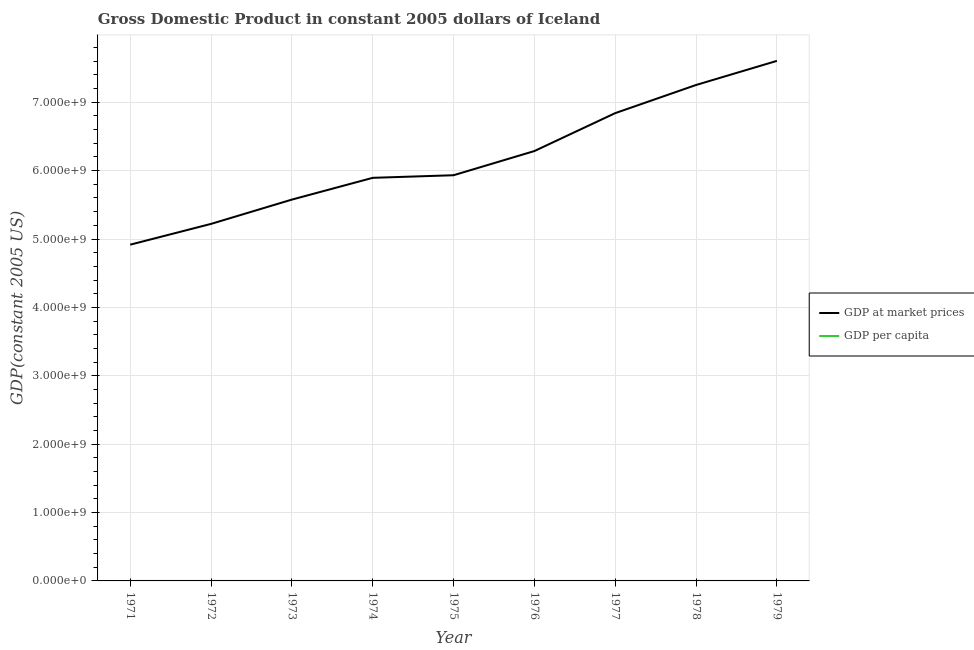How many different coloured lines are there?
Keep it short and to the point. 2. Is the number of lines equal to the number of legend labels?
Provide a succinct answer. Yes. What is the gdp at market prices in 1976?
Offer a very short reply. 6.29e+09. Across all years, what is the maximum gdp at market prices?
Your response must be concise. 7.61e+09. Across all years, what is the minimum gdp per capita?
Keep it short and to the point. 2.39e+04. In which year was the gdp per capita maximum?
Offer a terse response. 1979. In which year was the gdp at market prices minimum?
Make the answer very short. 1971. What is the total gdp at market prices in the graph?
Your answer should be very brief. 5.55e+1. What is the difference between the gdp per capita in 1972 and that in 1979?
Provide a short and direct response. -8725.14. What is the difference between the gdp at market prices in 1974 and the gdp per capita in 1976?
Give a very brief answer. 5.89e+09. What is the average gdp at market prices per year?
Give a very brief answer. 6.17e+09. In the year 1975, what is the difference between the gdp at market prices and gdp per capita?
Provide a short and direct response. 5.93e+09. In how many years, is the gdp per capita greater than 4200000000 US$?
Provide a succinct answer. 0. What is the ratio of the gdp per capita in 1971 to that in 1974?
Your answer should be compact. 0.87. Is the difference between the gdp per capita in 1971 and 1974 greater than the difference between the gdp at market prices in 1971 and 1974?
Keep it short and to the point. Yes. What is the difference between the highest and the second highest gdp at market prices?
Provide a succinct answer. 3.53e+08. What is the difference between the highest and the lowest gdp at market prices?
Your answer should be very brief. 2.69e+09. Is the gdp per capita strictly greater than the gdp at market prices over the years?
Give a very brief answer. No. Is the gdp per capita strictly less than the gdp at market prices over the years?
Provide a succinct answer. Yes. What is the difference between two consecutive major ticks on the Y-axis?
Keep it short and to the point. 1.00e+09. Are the values on the major ticks of Y-axis written in scientific E-notation?
Ensure brevity in your answer.  Yes. Does the graph contain grids?
Keep it short and to the point. Yes. How many legend labels are there?
Your answer should be very brief. 2. What is the title of the graph?
Offer a very short reply. Gross Domestic Product in constant 2005 dollars of Iceland. Does "From human activities" appear as one of the legend labels in the graph?
Your response must be concise. No. What is the label or title of the X-axis?
Keep it short and to the point. Year. What is the label or title of the Y-axis?
Keep it short and to the point. GDP(constant 2005 US). What is the GDP(constant 2005 US) in GDP at market prices in 1971?
Provide a succinct answer. 4.92e+09. What is the GDP(constant 2005 US) in GDP per capita in 1971?
Offer a terse response. 2.39e+04. What is the GDP(constant 2005 US) of GDP at market prices in 1972?
Provide a short and direct response. 5.22e+09. What is the GDP(constant 2005 US) of GDP per capita in 1972?
Ensure brevity in your answer.  2.50e+04. What is the GDP(constant 2005 US) in GDP at market prices in 1973?
Provide a succinct answer. 5.58e+09. What is the GDP(constant 2005 US) of GDP per capita in 1973?
Give a very brief answer. 2.63e+04. What is the GDP(constant 2005 US) in GDP at market prices in 1974?
Your response must be concise. 5.89e+09. What is the GDP(constant 2005 US) of GDP per capita in 1974?
Ensure brevity in your answer.  2.74e+04. What is the GDP(constant 2005 US) of GDP at market prices in 1975?
Keep it short and to the point. 5.93e+09. What is the GDP(constant 2005 US) of GDP per capita in 1975?
Offer a very short reply. 2.72e+04. What is the GDP(constant 2005 US) in GDP at market prices in 1976?
Your response must be concise. 6.29e+09. What is the GDP(constant 2005 US) of GDP per capita in 1976?
Offer a very short reply. 2.86e+04. What is the GDP(constant 2005 US) of GDP at market prices in 1977?
Give a very brief answer. 6.84e+09. What is the GDP(constant 2005 US) of GDP per capita in 1977?
Provide a short and direct response. 3.08e+04. What is the GDP(constant 2005 US) of GDP at market prices in 1978?
Ensure brevity in your answer.  7.25e+09. What is the GDP(constant 2005 US) in GDP per capita in 1978?
Give a very brief answer. 3.24e+04. What is the GDP(constant 2005 US) of GDP at market prices in 1979?
Offer a very short reply. 7.61e+09. What is the GDP(constant 2005 US) of GDP per capita in 1979?
Offer a terse response. 3.37e+04. Across all years, what is the maximum GDP(constant 2005 US) in GDP at market prices?
Provide a succinct answer. 7.61e+09. Across all years, what is the maximum GDP(constant 2005 US) of GDP per capita?
Make the answer very short. 3.37e+04. Across all years, what is the minimum GDP(constant 2005 US) in GDP at market prices?
Ensure brevity in your answer.  4.92e+09. Across all years, what is the minimum GDP(constant 2005 US) in GDP per capita?
Make the answer very short. 2.39e+04. What is the total GDP(constant 2005 US) in GDP at market prices in the graph?
Your response must be concise. 5.55e+1. What is the total GDP(constant 2005 US) of GDP per capita in the graph?
Ensure brevity in your answer.  2.55e+05. What is the difference between the GDP(constant 2005 US) in GDP at market prices in 1971 and that in 1972?
Provide a short and direct response. -3.04e+08. What is the difference between the GDP(constant 2005 US) in GDP per capita in 1971 and that in 1972?
Your answer should be very brief. -1105.76. What is the difference between the GDP(constant 2005 US) in GDP at market prices in 1971 and that in 1973?
Give a very brief answer. -6.59e+08. What is the difference between the GDP(constant 2005 US) of GDP per capita in 1971 and that in 1973?
Ensure brevity in your answer.  -2405.54. What is the difference between the GDP(constant 2005 US) in GDP at market prices in 1971 and that in 1974?
Offer a terse response. -9.77e+08. What is the difference between the GDP(constant 2005 US) of GDP per capita in 1971 and that in 1974?
Ensure brevity in your answer.  -3531.21. What is the difference between the GDP(constant 2005 US) in GDP at market prices in 1971 and that in 1975?
Keep it short and to the point. -1.02e+09. What is the difference between the GDP(constant 2005 US) of GDP per capita in 1971 and that in 1975?
Provide a short and direct response. -3357.88. What is the difference between the GDP(constant 2005 US) of GDP at market prices in 1971 and that in 1976?
Make the answer very short. -1.37e+09. What is the difference between the GDP(constant 2005 US) in GDP per capita in 1971 and that in 1976?
Make the answer very short. -4694.95. What is the difference between the GDP(constant 2005 US) of GDP at market prices in 1971 and that in 1977?
Your answer should be compact. -1.92e+09. What is the difference between the GDP(constant 2005 US) of GDP per capita in 1971 and that in 1977?
Give a very brief answer. -6983.65. What is the difference between the GDP(constant 2005 US) in GDP at market prices in 1971 and that in 1978?
Make the answer very short. -2.34e+09. What is the difference between the GDP(constant 2005 US) in GDP per capita in 1971 and that in 1978?
Provide a succinct answer. -8585.17. What is the difference between the GDP(constant 2005 US) in GDP at market prices in 1971 and that in 1979?
Ensure brevity in your answer.  -2.69e+09. What is the difference between the GDP(constant 2005 US) in GDP per capita in 1971 and that in 1979?
Provide a succinct answer. -9830.9. What is the difference between the GDP(constant 2005 US) of GDP at market prices in 1972 and that in 1973?
Provide a succinct answer. -3.55e+08. What is the difference between the GDP(constant 2005 US) of GDP per capita in 1972 and that in 1973?
Your answer should be compact. -1299.78. What is the difference between the GDP(constant 2005 US) of GDP at market prices in 1972 and that in 1974?
Your answer should be compact. -6.74e+08. What is the difference between the GDP(constant 2005 US) of GDP per capita in 1972 and that in 1974?
Offer a terse response. -2425.45. What is the difference between the GDP(constant 2005 US) of GDP at market prices in 1972 and that in 1975?
Provide a succinct answer. -7.12e+08. What is the difference between the GDP(constant 2005 US) of GDP per capita in 1972 and that in 1975?
Provide a short and direct response. -2252.11. What is the difference between the GDP(constant 2005 US) in GDP at market prices in 1972 and that in 1976?
Keep it short and to the point. -1.07e+09. What is the difference between the GDP(constant 2005 US) in GDP per capita in 1972 and that in 1976?
Provide a short and direct response. -3589.19. What is the difference between the GDP(constant 2005 US) in GDP at market prices in 1972 and that in 1977?
Keep it short and to the point. -1.62e+09. What is the difference between the GDP(constant 2005 US) of GDP per capita in 1972 and that in 1977?
Your answer should be very brief. -5877.89. What is the difference between the GDP(constant 2005 US) of GDP at market prices in 1972 and that in 1978?
Offer a very short reply. -2.03e+09. What is the difference between the GDP(constant 2005 US) in GDP per capita in 1972 and that in 1978?
Your answer should be very brief. -7479.4. What is the difference between the GDP(constant 2005 US) in GDP at market prices in 1972 and that in 1979?
Offer a very short reply. -2.38e+09. What is the difference between the GDP(constant 2005 US) in GDP per capita in 1972 and that in 1979?
Your response must be concise. -8725.14. What is the difference between the GDP(constant 2005 US) of GDP at market prices in 1973 and that in 1974?
Offer a very short reply. -3.18e+08. What is the difference between the GDP(constant 2005 US) of GDP per capita in 1973 and that in 1974?
Offer a terse response. -1125.67. What is the difference between the GDP(constant 2005 US) in GDP at market prices in 1973 and that in 1975?
Your answer should be compact. -3.56e+08. What is the difference between the GDP(constant 2005 US) of GDP per capita in 1973 and that in 1975?
Offer a very short reply. -952.34. What is the difference between the GDP(constant 2005 US) of GDP at market prices in 1973 and that in 1976?
Your answer should be very brief. -7.10e+08. What is the difference between the GDP(constant 2005 US) of GDP per capita in 1973 and that in 1976?
Offer a terse response. -2289.41. What is the difference between the GDP(constant 2005 US) in GDP at market prices in 1973 and that in 1977?
Your response must be concise. -1.26e+09. What is the difference between the GDP(constant 2005 US) of GDP per capita in 1973 and that in 1977?
Your answer should be very brief. -4578.11. What is the difference between the GDP(constant 2005 US) of GDP at market prices in 1973 and that in 1978?
Provide a succinct answer. -1.68e+09. What is the difference between the GDP(constant 2005 US) of GDP per capita in 1973 and that in 1978?
Keep it short and to the point. -6179.63. What is the difference between the GDP(constant 2005 US) of GDP at market prices in 1973 and that in 1979?
Provide a succinct answer. -2.03e+09. What is the difference between the GDP(constant 2005 US) of GDP per capita in 1973 and that in 1979?
Offer a terse response. -7425.36. What is the difference between the GDP(constant 2005 US) in GDP at market prices in 1974 and that in 1975?
Your answer should be very brief. -3.81e+07. What is the difference between the GDP(constant 2005 US) in GDP per capita in 1974 and that in 1975?
Provide a short and direct response. 173.33. What is the difference between the GDP(constant 2005 US) of GDP at market prices in 1974 and that in 1976?
Offer a very short reply. -3.92e+08. What is the difference between the GDP(constant 2005 US) in GDP per capita in 1974 and that in 1976?
Provide a short and direct response. -1163.74. What is the difference between the GDP(constant 2005 US) in GDP at market prices in 1974 and that in 1977?
Your answer should be compact. -9.46e+08. What is the difference between the GDP(constant 2005 US) of GDP per capita in 1974 and that in 1977?
Keep it short and to the point. -3452.44. What is the difference between the GDP(constant 2005 US) of GDP at market prices in 1974 and that in 1978?
Your response must be concise. -1.36e+09. What is the difference between the GDP(constant 2005 US) of GDP per capita in 1974 and that in 1978?
Offer a very short reply. -5053.96. What is the difference between the GDP(constant 2005 US) in GDP at market prices in 1974 and that in 1979?
Your answer should be compact. -1.71e+09. What is the difference between the GDP(constant 2005 US) in GDP per capita in 1974 and that in 1979?
Provide a short and direct response. -6299.69. What is the difference between the GDP(constant 2005 US) in GDP at market prices in 1975 and that in 1976?
Your answer should be very brief. -3.54e+08. What is the difference between the GDP(constant 2005 US) in GDP per capita in 1975 and that in 1976?
Provide a succinct answer. -1337.07. What is the difference between the GDP(constant 2005 US) in GDP at market prices in 1975 and that in 1977?
Offer a very short reply. -9.08e+08. What is the difference between the GDP(constant 2005 US) of GDP per capita in 1975 and that in 1977?
Offer a terse response. -3625.77. What is the difference between the GDP(constant 2005 US) of GDP at market prices in 1975 and that in 1978?
Ensure brevity in your answer.  -1.32e+09. What is the difference between the GDP(constant 2005 US) of GDP per capita in 1975 and that in 1978?
Ensure brevity in your answer.  -5227.29. What is the difference between the GDP(constant 2005 US) of GDP at market prices in 1975 and that in 1979?
Ensure brevity in your answer.  -1.67e+09. What is the difference between the GDP(constant 2005 US) in GDP per capita in 1975 and that in 1979?
Ensure brevity in your answer.  -6473.02. What is the difference between the GDP(constant 2005 US) in GDP at market prices in 1976 and that in 1977?
Make the answer very short. -5.55e+08. What is the difference between the GDP(constant 2005 US) in GDP per capita in 1976 and that in 1977?
Make the answer very short. -2288.7. What is the difference between the GDP(constant 2005 US) in GDP at market prices in 1976 and that in 1978?
Your answer should be very brief. -9.66e+08. What is the difference between the GDP(constant 2005 US) in GDP per capita in 1976 and that in 1978?
Ensure brevity in your answer.  -3890.22. What is the difference between the GDP(constant 2005 US) of GDP at market prices in 1976 and that in 1979?
Keep it short and to the point. -1.32e+09. What is the difference between the GDP(constant 2005 US) in GDP per capita in 1976 and that in 1979?
Give a very brief answer. -5135.95. What is the difference between the GDP(constant 2005 US) of GDP at market prices in 1977 and that in 1978?
Give a very brief answer. -4.12e+08. What is the difference between the GDP(constant 2005 US) in GDP per capita in 1977 and that in 1978?
Your response must be concise. -1601.52. What is the difference between the GDP(constant 2005 US) in GDP at market prices in 1977 and that in 1979?
Give a very brief answer. -7.64e+08. What is the difference between the GDP(constant 2005 US) of GDP per capita in 1977 and that in 1979?
Offer a very short reply. -2847.25. What is the difference between the GDP(constant 2005 US) in GDP at market prices in 1978 and that in 1979?
Keep it short and to the point. -3.53e+08. What is the difference between the GDP(constant 2005 US) of GDP per capita in 1978 and that in 1979?
Provide a short and direct response. -1245.73. What is the difference between the GDP(constant 2005 US) in GDP at market prices in 1971 and the GDP(constant 2005 US) in GDP per capita in 1972?
Make the answer very short. 4.92e+09. What is the difference between the GDP(constant 2005 US) in GDP at market prices in 1971 and the GDP(constant 2005 US) in GDP per capita in 1973?
Keep it short and to the point. 4.92e+09. What is the difference between the GDP(constant 2005 US) in GDP at market prices in 1971 and the GDP(constant 2005 US) in GDP per capita in 1974?
Your answer should be very brief. 4.92e+09. What is the difference between the GDP(constant 2005 US) in GDP at market prices in 1971 and the GDP(constant 2005 US) in GDP per capita in 1975?
Provide a short and direct response. 4.92e+09. What is the difference between the GDP(constant 2005 US) of GDP at market prices in 1971 and the GDP(constant 2005 US) of GDP per capita in 1976?
Keep it short and to the point. 4.92e+09. What is the difference between the GDP(constant 2005 US) of GDP at market prices in 1971 and the GDP(constant 2005 US) of GDP per capita in 1977?
Offer a terse response. 4.92e+09. What is the difference between the GDP(constant 2005 US) of GDP at market prices in 1971 and the GDP(constant 2005 US) of GDP per capita in 1978?
Keep it short and to the point. 4.92e+09. What is the difference between the GDP(constant 2005 US) of GDP at market prices in 1971 and the GDP(constant 2005 US) of GDP per capita in 1979?
Provide a short and direct response. 4.92e+09. What is the difference between the GDP(constant 2005 US) in GDP at market prices in 1972 and the GDP(constant 2005 US) in GDP per capita in 1973?
Your answer should be compact. 5.22e+09. What is the difference between the GDP(constant 2005 US) in GDP at market prices in 1972 and the GDP(constant 2005 US) in GDP per capita in 1974?
Your answer should be compact. 5.22e+09. What is the difference between the GDP(constant 2005 US) in GDP at market prices in 1972 and the GDP(constant 2005 US) in GDP per capita in 1975?
Ensure brevity in your answer.  5.22e+09. What is the difference between the GDP(constant 2005 US) of GDP at market prices in 1972 and the GDP(constant 2005 US) of GDP per capita in 1976?
Ensure brevity in your answer.  5.22e+09. What is the difference between the GDP(constant 2005 US) of GDP at market prices in 1972 and the GDP(constant 2005 US) of GDP per capita in 1977?
Ensure brevity in your answer.  5.22e+09. What is the difference between the GDP(constant 2005 US) in GDP at market prices in 1972 and the GDP(constant 2005 US) in GDP per capita in 1978?
Your answer should be very brief. 5.22e+09. What is the difference between the GDP(constant 2005 US) of GDP at market prices in 1972 and the GDP(constant 2005 US) of GDP per capita in 1979?
Make the answer very short. 5.22e+09. What is the difference between the GDP(constant 2005 US) in GDP at market prices in 1973 and the GDP(constant 2005 US) in GDP per capita in 1974?
Make the answer very short. 5.58e+09. What is the difference between the GDP(constant 2005 US) of GDP at market prices in 1973 and the GDP(constant 2005 US) of GDP per capita in 1975?
Offer a terse response. 5.58e+09. What is the difference between the GDP(constant 2005 US) in GDP at market prices in 1973 and the GDP(constant 2005 US) in GDP per capita in 1976?
Provide a short and direct response. 5.58e+09. What is the difference between the GDP(constant 2005 US) of GDP at market prices in 1973 and the GDP(constant 2005 US) of GDP per capita in 1977?
Keep it short and to the point. 5.58e+09. What is the difference between the GDP(constant 2005 US) in GDP at market prices in 1973 and the GDP(constant 2005 US) in GDP per capita in 1978?
Keep it short and to the point. 5.58e+09. What is the difference between the GDP(constant 2005 US) of GDP at market prices in 1973 and the GDP(constant 2005 US) of GDP per capita in 1979?
Provide a succinct answer. 5.58e+09. What is the difference between the GDP(constant 2005 US) of GDP at market prices in 1974 and the GDP(constant 2005 US) of GDP per capita in 1975?
Your response must be concise. 5.89e+09. What is the difference between the GDP(constant 2005 US) in GDP at market prices in 1974 and the GDP(constant 2005 US) in GDP per capita in 1976?
Keep it short and to the point. 5.89e+09. What is the difference between the GDP(constant 2005 US) in GDP at market prices in 1974 and the GDP(constant 2005 US) in GDP per capita in 1977?
Give a very brief answer. 5.89e+09. What is the difference between the GDP(constant 2005 US) of GDP at market prices in 1974 and the GDP(constant 2005 US) of GDP per capita in 1978?
Keep it short and to the point. 5.89e+09. What is the difference between the GDP(constant 2005 US) of GDP at market prices in 1974 and the GDP(constant 2005 US) of GDP per capita in 1979?
Keep it short and to the point. 5.89e+09. What is the difference between the GDP(constant 2005 US) of GDP at market prices in 1975 and the GDP(constant 2005 US) of GDP per capita in 1976?
Your response must be concise. 5.93e+09. What is the difference between the GDP(constant 2005 US) of GDP at market prices in 1975 and the GDP(constant 2005 US) of GDP per capita in 1977?
Your answer should be compact. 5.93e+09. What is the difference between the GDP(constant 2005 US) of GDP at market prices in 1975 and the GDP(constant 2005 US) of GDP per capita in 1978?
Make the answer very short. 5.93e+09. What is the difference between the GDP(constant 2005 US) in GDP at market prices in 1975 and the GDP(constant 2005 US) in GDP per capita in 1979?
Give a very brief answer. 5.93e+09. What is the difference between the GDP(constant 2005 US) in GDP at market prices in 1976 and the GDP(constant 2005 US) in GDP per capita in 1977?
Give a very brief answer. 6.29e+09. What is the difference between the GDP(constant 2005 US) in GDP at market prices in 1976 and the GDP(constant 2005 US) in GDP per capita in 1978?
Your answer should be compact. 6.29e+09. What is the difference between the GDP(constant 2005 US) of GDP at market prices in 1976 and the GDP(constant 2005 US) of GDP per capita in 1979?
Provide a succinct answer. 6.29e+09. What is the difference between the GDP(constant 2005 US) in GDP at market prices in 1977 and the GDP(constant 2005 US) in GDP per capita in 1978?
Offer a very short reply. 6.84e+09. What is the difference between the GDP(constant 2005 US) of GDP at market prices in 1977 and the GDP(constant 2005 US) of GDP per capita in 1979?
Make the answer very short. 6.84e+09. What is the difference between the GDP(constant 2005 US) of GDP at market prices in 1978 and the GDP(constant 2005 US) of GDP per capita in 1979?
Provide a succinct answer. 7.25e+09. What is the average GDP(constant 2005 US) in GDP at market prices per year?
Give a very brief answer. 6.17e+09. What is the average GDP(constant 2005 US) of GDP per capita per year?
Your response must be concise. 2.84e+04. In the year 1971, what is the difference between the GDP(constant 2005 US) in GDP at market prices and GDP(constant 2005 US) in GDP per capita?
Provide a short and direct response. 4.92e+09. In the year 1972, what is the difference between the GDP(constant 2005 US) in GDP at market prices and GDP(constant 2005 US) in GDP per capita?
Offer a terse response. 5.22e+09. In the year 1973, what is the difference between the GDP(constant 2005 US) of GDP at market prices and GDP(constant 2005 US) of GDP per capita?
Give a very brief answer. 5.58e+09. In the year 1974, what is the difference between the GDP(constant 2005 US) of GDP at market prices and GDP(constant 2005 US) of GDP per capita?
Make the answer very short. 5.89e+09. In the year 1975, what is the difference between the GDP(constant 2005 US) in GDP at market prices and GDP(constant 2005 US) in GDP per capita?
Your answer should be compact. 5.93e+09. In the year 1976, what is the difference between the GDP(constant 2005 US) in GDP at market prices and GDP(constant 2005 US) in GDP per capita?
Your answer should be compact. 6.29e+09. In the year 1977, what is the difference between the GDP(constant 2005 US) in GDP at market prices and GDP(constant 2005 US) in GDP per capita?
Provide a succinct answer. 6.84e+09. In the year 1978, what is the difference between the GDP(constant 2005 US) in GDP at market prices and GDP(constant 2005 US) in GDP per capita?
Give a very brief answer. 7.25e+09. In the year 1979, what is the difference between the GDP(constant 2005 US) in GDP at market prices and GDP(constant 2005 US) in GDP per capita?
Provide a short and direct response. 7.61e+09. What is the ratio of the GDP(constant 2005 US) in GDP at market prices in 1971 to that in 1972?
Provide a short and direct response. 0.94. What is the ratio of the GDP(constant 2005 US) of GDP per capita in 1971 to that in 1972?
Ensure brevity in your answer.  0.96. What is the ratio of the GDP(constant 2005 US) in GDP at market prices in 1971 to that in 1973?
Offer a very short reply. 0.88. What is the ratio of the GDP(constant 2005 US) in GDP per capita in 1971 to that in 1973?
Your answer should be very brief. 0.91. What is the ratio of the GDP(constant 2005 US) in GDP at market prices in 1971 to that in 1974?
Your answer should be very brief. 0.83. What is the ratio of the GDP(constant 2005 US) of GDP per capita in 1971 to that in 1974?
Provide a short and direct response. 0.87. What is the ratio of the GDP(constant 2005 US) of GDP at market prices in 1971 to that in 1975?
Provide a succinct answer. 0.83. What is the ratio of the GDP(constant 2005 US) in GDP per capita in 1971 to that in 1975?
Your answer should be very brief. 0.88. What is the ratio of the GDP(constant 2005 US) of GDP at market prices in 1971 to that in 1976?
Provide a succinct answer. 0.78. What is the ratio of the GDP(constant 2005 US) in GDP per capita in 1971 to that in 1976?
Your response must be concise. 0.84. What is the ratio of the GDP(constant 2005 US) in GDP at market prices in 1971 to that in 1977?
Give a very brief answer. 0.72. What is the ratio of the GDP(constant 2005 US) in GDP per capita in 1971 to that in 1977?
Give a very brief answer. 0.77. What is the ratio of the GDP(constant 2005 US) in GDP at market prices in 1971 to that in 1978?
Ensure brevity in your answer.  0.68. What is the ratio of the GDP(constant 2005 US) in GDP per capita in 1971 to that in 1978?
Keep it short and to the point. 0.74. What is the ratio of the GDP(constant 2005 US) in GDP at market prices in 1971 to that in 1979?
Give a very brief answer. 0.65. What is the ratio of the GDP(constant 2005 US) of GDP per capita in 1971 to that in 1979?
Give a very brief answer. 0.71. What is the ratio of the GDP(constant 2005 US) in GDP at market prices in 1972 to that in 1973?
Your response must be concise. 0.94. What is the ratio of the GDP(constant 2005 US) in GDP per capita in 1972 to that in 1973?
Ensure brevity in your answer.  0.95. What is the ratio of the GDP(constant 2005 US) in GDP at market prices in 1972 to that in 1974?
Ensure brevity in your answer.  0.89. What is the ratio of the GDP(constant 2005 US) of GDP per capita in 1972 to that in 1974?
Offer a terse response. 0.91. What is the ratio of the GDP(constant 2005 US) in GDP at market prices in 1972 to that in 1975?
Give a very brief answer. 0.88. What is the ratio of the GDP(constant 2005 US) of GDP per capita in 1972 to that in 1975?
Your response must be concise. 0.92. What is the ratio of the GDP(constant 2005 US) in GDP at market prices in 1972 to that in 1976?
Provide a succinct answer. 0.83. What is the ratio of the GDP(constant 2005 US) in GDP per capita in 1972 to that in 1976?
Give a very brief answer. 0.87. What is the ratio of the GDP(constant 2005 US) of GDP at market prices in 1972 to that in 1977?
Offer a terse response. 0.76. What is the ratio of the GDP(constant 2005 US) in GDP per capita in 1972 to that in 1977?
Make the answer very short. 0.81. What is the ratio of the GDP(constant 2005 US) of GDP at market prices in 1972 to that in 1978?
Ensure brevity in your answer.  0.72. What is the ratio of the GDP(constant 2005 US) of GDP per capita in 1972 to that in 1978?
Provide a succinct answer. 0.77. What is the ratio of the GDP(constant 2005 US) of GDP at market prices in 1972 to that in 1979?
Ensure brevity in your answer.  0.69. What is the ratio of the GDP(constant 2005 US) in GDP per capita in 1972 to that in 1979?
Keep it short and to the point. 0.74. What is the ratio of the GDP(constant 2005 US) in GDP at market prices in 1973 to that in 1974?
Offer a very short reply. 0.95. What is the ratio of the GDP(constant 2005 US) in GDP per capita in 1973 to that in 1974?
Your response must be concise. 0.96. What is the ratio of the GDP(constant 2005 US) in GDP at market prices in 1973 to that in 1975?
Make the answer very short. 0.94. What is the ratio of the GDP(constant 2005 US) of GDP per capita in 1973 to that in 1975?
Your answer should be very brief. 0.96. What is the ratio of the GDP(constant 2005 US) of GDP at market prices in 1973 to that in 1976?
Your answer should be compact. 0.89. What is the ratio of the GDP(constant 2005 US) in GDP per capita in 1973 to that in 1976?
Provide a short and direct response. 0.92. What is the ratio of the GDP(constant 2005 US) of GDP at market prices in 1973 to that in 1977?
Offer a terse response. 0.82. What is the ratio of the GDP(constant 2005 US) of GDP per capita in 1973 to that in 1977?
Ensure brevity in your answer.  0.85. What is the ratio of the GDP(constant 2005 US) in GDP at market prices in 1973 to that in 1978?
Your answer should be very brief. 0.77. What is the ratio of the GDP(constant 2005 US) in GDP per capita in 1973 to that in 1978?
Offer a very short reply. 0.81. What is the ratio of the GDP(constant 2005 US) of GDP at market prices in 1973 to that in 1979?
Your answer should be very brief. 0.73. What is the ratio of the GDP(constant 2005 US) of GDP per capita in 1973 to that in 1979?
Your response must be concise. 0.78. What is the ratio of the GDP(constant 2005 US) in GDP per capita in 1974 to that in 1975?
Provide a succinct answer. 1.01. What is the ratio of the GDP(constant 2005 US) in GDP at market prices in 1974 to that in 1976?
Provide a succinct answer. 0.94. What is the ratio of the GDP(constant 2005 US) in GDP per capita in 1974 to that in 1976?
Make the answer very short. 0.96. What is the ratio of the GDP(constant 2005 US) of GDP at market prices in 1974 to that in 1977?
Keep it short and to the point. 0.86. What is the ratio of the GDP(constant 2005 US) in GDP per capita in 1974 to that in 1977?
Ensure brevity in your answer.  0.89. What is the ratio of the GDP(constant 2005 US) of GDP at market prices in 1974 to that in 1978?
Make the answer very short. 0.81. What is the ratio of the GDP(constant 2005 US) in GDP per capita in 1974 to that in 1978?
Give a very brief answer. 0.84. What is the ratio of the GDP(constant 2005 US) in GDP at market prices in 1974 to that in 1979?
Provide a short and direct response. 0.78. What is the ratio of the GDP(constant 2005 US) in GDP per capita in 1974 to that in 1979?
Your response must be concise. 0.81. What is the ratio of the GDP(constant 2005 US) of GDP at market prices in 1975 to that in 1976?
Provide a short and direct response. 0.94. What is the ratio of the GDP(constant 2005 US) of GDP per capita in 1975 to that in 1976?
Ensure brevity in your answer.  0.95. What is the ratio of the GDP(constant 2005 US) of GDP at market prices in 1975 to that in 1977?
Your response must be concise. 0.87. What is the ratio of the GDP(constant 2005 US) in GDP per capita in 1975 to that in 1977?
Offer a terse response. 0.88. What is the ratio of the GDP(constant 2005 US) of GDP at market prices in 1975 to that in 1978?
Your answer should be compact. 0.82. What is the ratio of the GDP(constant 2005 US) in GDP per capita in 1975 to that in 1978?
Provide a short and direct response. 0.84. What is the ratio of the GDP(constant 2005 US) of GDP at market prices in 1975 to that in 1979?
Provide a succinct answer. 0.78. What is the ratio of the GDP(constant 2005 US) of GDP per capita in 1975 to that in 1979?
Provide a short and direct response. 0.81. What is the ratio of the GDP(constant 2005 US) in GDP at market prices in 1976 to that in 1977?
Your response must be concise. 0.92. What is the ratio of the GDP(constant 2005 US) of GDP per capita in 1976 to that in 1977?
Offer a terse response. 0.93. What is the ratio of the GDP(constant 2005 US) in GDP at market prices in 1976 to that in 1978?
Give a very brief answer. 0.87. What is the ratio of the GDP(constant 2005 US) of GDP per capita in 1976 to that in 1978?
Offer a terse response. 0.88. What is the ratio of the GDP(constant 2005 US) in GDP at market prices in 1976 to that in 1979?
Give a very brief answer. 0.83. What is the ratio of the GDP(constant 2005 US) in GDP per capita in 1976 to that in 1979?
Provide a succinct answer. 0.85. What is the ratio of the GDP(constant 2005 US) of GDP at market prices in 1977 to that in 1978?
Your answer should be compact. 0.94. What is the ratio of the GDP(constant 2005 US) of GDP per capita in 1977 to that in 1978?
Your response must be concise. 0.95. What is the ratio of the GDP(constant 2005 US) of GDP at market prices in 1977 to that in 1979?
Give a very brief answer. 0.9. What is the ratio of the GDP(constant 2005 US) of GDP per capita in 1977 to that in 1979?
Give a very brief answer. 0.92. What is the ratio of the GDP(constant 2005 US) in GDP at market prices in 1978 to that in 1979?
Provide a succinct answer. 0.95. What is the ratio of the GDP(constant 2005 US) in GDP per capita in 1978 to that in 1979?
Offer a terse response. 0.96. What is the difference between the highest and the second highest GDP(constant 2005 US) of GDP at market prices?
Your answer should be very brief. 3.53e+08. What is the difference between the highest and the second highest GDP(constant 2005 US) of GDP per capita?
Your answer should be compact. 1245.73. What is the difference between the highest and the lowest GDP(constant 2005 US) of GDP at market prices?
Provide a short and direct response. 2.69e+09. What is the difference between the highest and the lowest GDP(constant 2005 US) of GDP per capita?
Make the answer very short. 9830.9. 